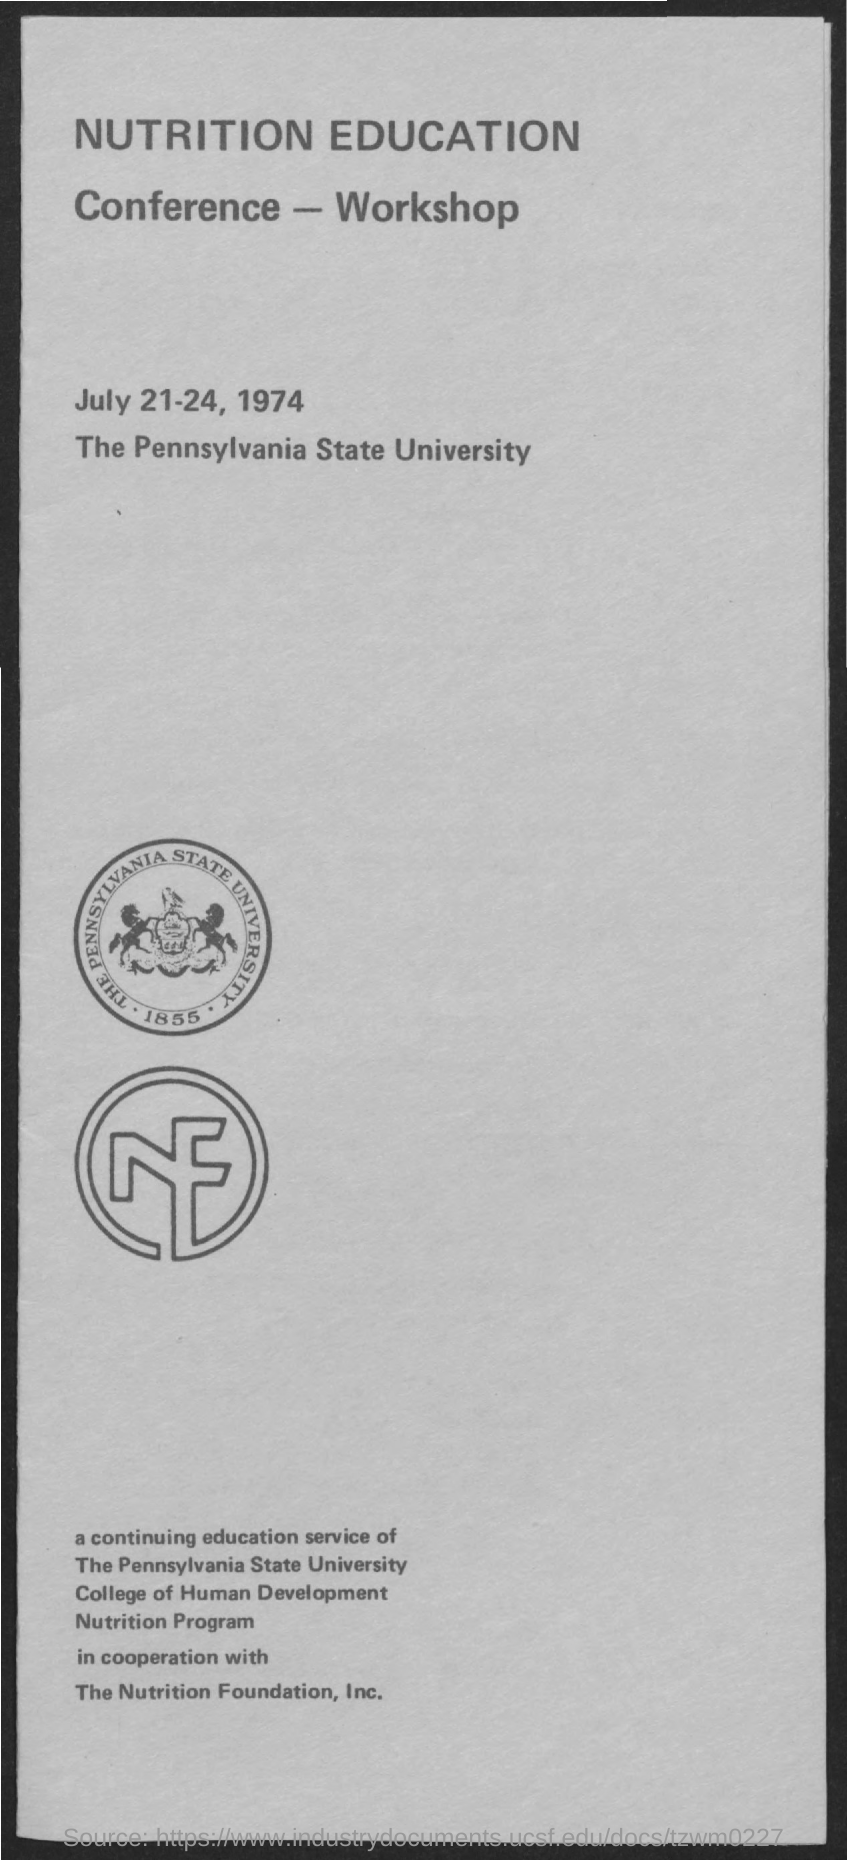When is the Conference- Workshop held?
Offer a very short reply. July 21-24, 1974. Where is the Conference- Workshop held?
Give a very brief answer. The Pennsylvania State University. 